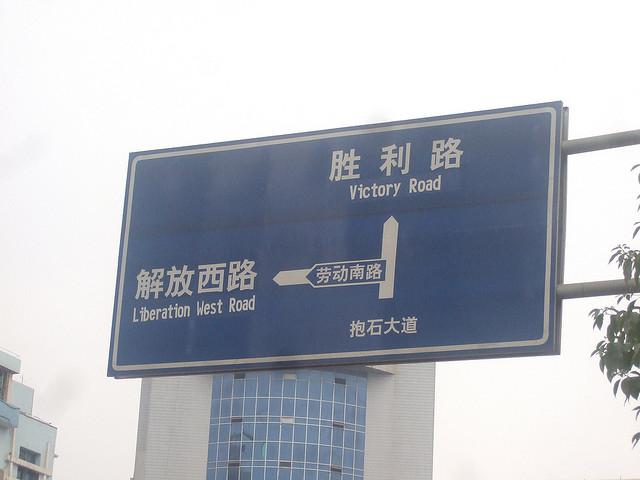Which direction should you not go?
Write a very short answer. Right. Is Victory Road straight ahead?
Write a very short answer. Yes. In what direction does the arrow point?
Short answer required. Left. What color is this sign?
Concise answer only. Blue. Are there directions to Liberty West Road?
Keep it brief. Yes. 